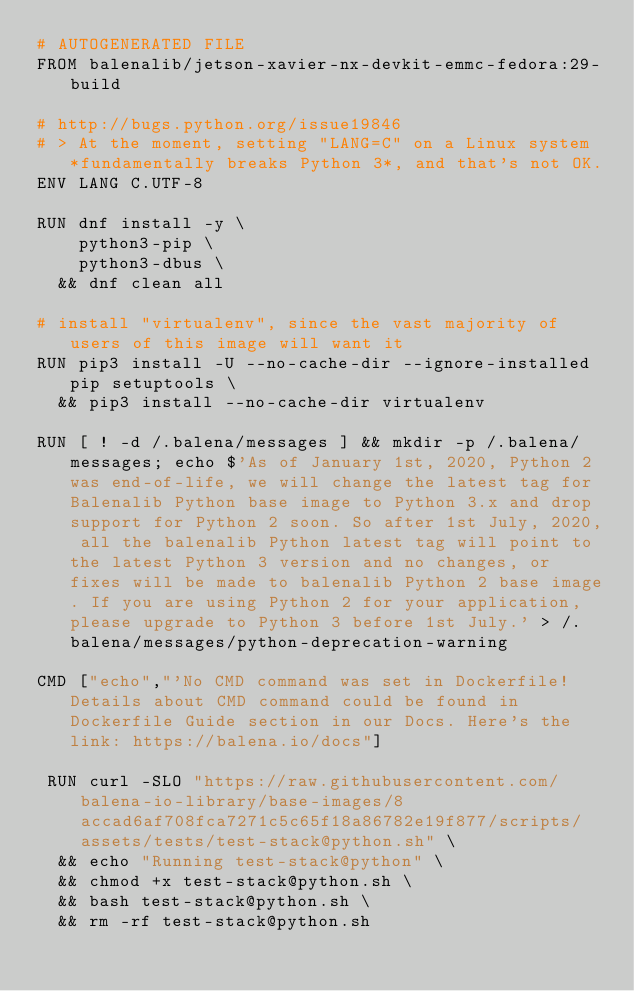Convert code to text. <code><loc_0><loc_0><loc_500><loc_500><_Dockerfile_># AUTOGENERATED FILE
FROM balenalib/jetson-xavier-nx-devkit-emmc-fedora:29-build

# http://bugs.python.org/issue19846
# > At the moment, setting "LANG=C" on a Linux system *fundamentally breaks Python 3*, and that's not OK.
ENV LANG C.UTF-8

RUN dnf install -y \
		python3-pip \
		python3-dbus \
	&& dnf clean all

# install "virtualenv", since the vast majority of users of this image will want it
RUN pip3 install -U --no-cache-dir --ignore-installed pip setuptools \
	&& pip3 install --no-cache-dir virtualenv

RUN [ ! -d /.balena/messages ] && mkdir -p /.balena/messages; echo $'As of January 1st, 2020, Python 2 was end-of-life, we will change the latest tag for Balenalib Python base image to Python 3.x and drop support for Python 2 soon. So after 1st July, 2020, all the balenalib Python latest tag will point to the latest Python 3 version and no changes, or fixes will be made to balenalib Python 2 base image. If you are using Python 2 for your application, please upgrade to Python 3 before 1st July.' > /.balena/messages/python-deprecation-warning

CMD ["echo","'No CMD command was set in Dockerfile! Details about CMD command could be found in Dockerfile Guide section in our Docs. Here's the link: https://balena.io/docs"]

 RUN curl -SLO "https://raw.githubusercontent.com/balena-io-library/base-images/8accad6af708fca7271c5c65f18a86782e19f877/scripts/assets/tests/test-stack@python.sh" \
  && echo "Running test-stack@python" \
  && chmod +x test-stack@python.sh \
  && bash test-stack@python.sh \
  && rm -rf test-stack@python.sh 
</code> 